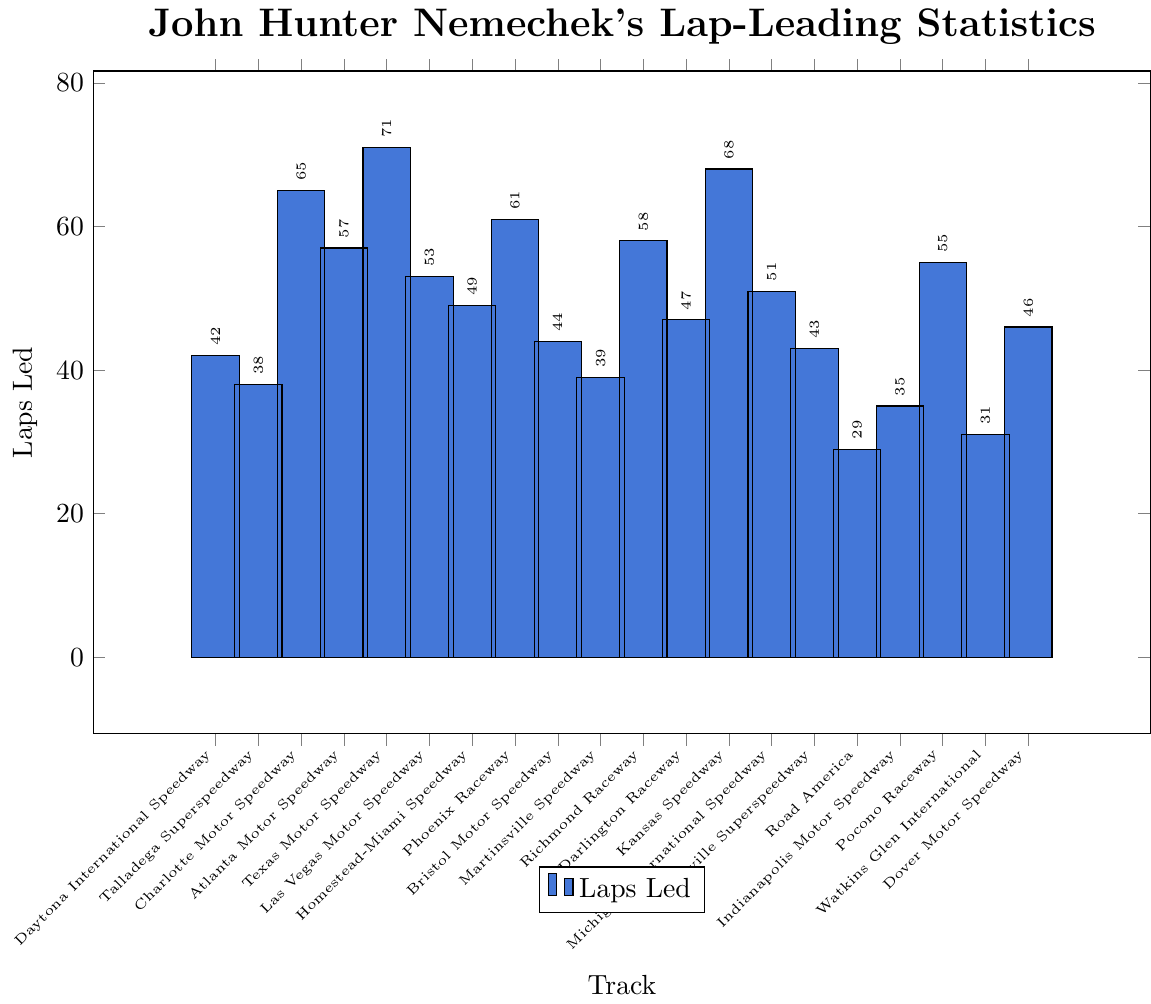What track has the highest number of laps led by John Hunter Nemechek? Look at the bar heights and identify the tallest one. The track with the tallest bar has the highest number of laps led.
Answer: Texas Motor Speedway How many more laps did John Hunter Nemechek lead at Texas Motor Speedway compared to Daytona International Speedway? Find the values for Texas Motor Speedway and Daytona International Speedway which are 71 and 42 respectively. Subtract the smaller value from the larger value: 71 - 42.
Answer: 29 What is the total number of laps led by John Hunter Nemechek across all speedways? Sum up the number of laps led across all tracks: 42 + 38 + 65 + 57 + 71 + 53 + 49 + 61 + 44 + 39 + 58 + 47 + 68 + 51 + 43 + 29 + 35 + 55 + 31 + 46.
Answer: 953 Which track has a greater number of laps led by John Hunter Nemechek, Kansas Speedway or Phoenix Raceway? Compare the number of laps led at Kansas Speedway (68) and Phoenix Raceway (61). Kansas Speedway has more laps led.
Answer: Kansas Speedway How many laps on average does John Hunter Nemechek lead per track? Calculate the total laps led (953) and divide by the number of tracks (20). The average is 953 / 20.
Answer: 47.65 Is the number of laps led at Michigan International Speedway closer to that at Homestead-Miami Speedway or Nashville Superspeedway? Find the laps led at Michigan International Speedway (51), Homestead-Miami Speedway (49), and Nashville Superspeedway (43). Calculate the differences:
Answer: Homestead-Miami Speedway What is the median number of laps led across all tracks? List the laps led in ascending order: 29, 31, 35, 38, 39, 42, 43, 44, 46, 47, 49, 51, 53, 55, 57, 58, 61, 65, 68, 71. The median is the middle value(s) of the sorted list. Here, it falls between the 10th and 11th values: (47+49)/2.
Answer: 48 Which tracks have fewer than 40 laps led by John Hunter Nemechek? Identify the tracks with bars shorter than the height representing 40 laps led: Talladega Superspeedway (38), Martinsville Speedway (39), Road America (29), Indianapolis Motor Speedway (35), and Watkins Glen International (31).
Answer: Talladega Superspeedway, Martinsville Speedway, Road America, Indianapolis Motor Speedway, Watkins Glen International On which track did John Hunter Nemechek lead twice as many laps as he did on Watkins Glen International? Find the laps led at Watkins Glen International (31) and double that value (2*31=62). Look for tracks with near 62 laps led; none are exact, but Phoenix Raceway (61) is closest.
Answer: Phoenix Raceway 